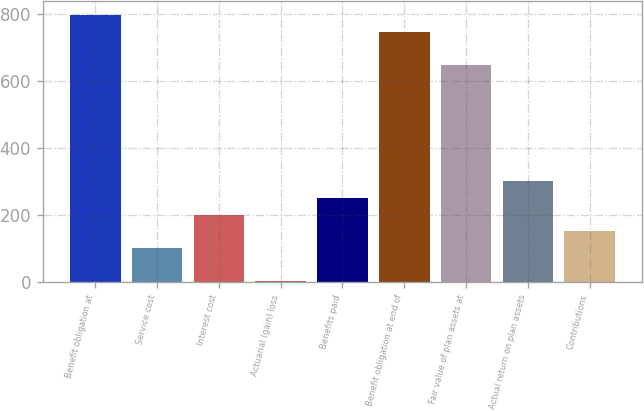Convert chart to OTSL. <chart><loc_0><loc_0><loc_500><loc_500><bar_chart><fcel>Benefit obligation at<fcel>Service cost<fcel>Interest cost<fcel>Actuarial (gain) loss<fcel>Benefits paid<fcel>Benefit obligation at end of<fcel>Fair value of plan assets at<fcel>Actual return on plan assets<fcel>Contributions<nl><fcel>798.36<fcel>101.72<fcel>201.24<fcel>2.2<fcel>251<fcel>748.6<fcel>649.08<fcel>300.76<fcel>151.48<nl></chart> 